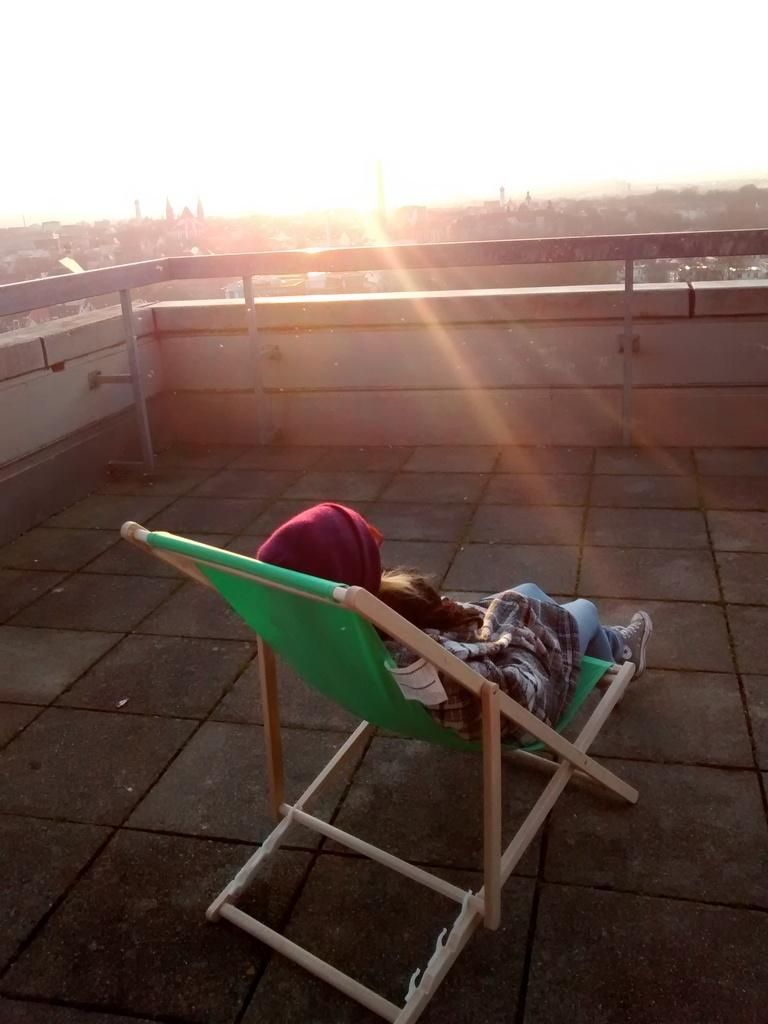What is the person in the image doing? The person is sitting on a chair in the image. What type of footwear is the person wearing? The person is wearing shoes. What can be seen in the background of the image? There is a sky, a tree, and a wall visible in the background. What type of seed is the person holding in their throat in the image? There is no seed or any indication of the person holding something in their throat in the image. 